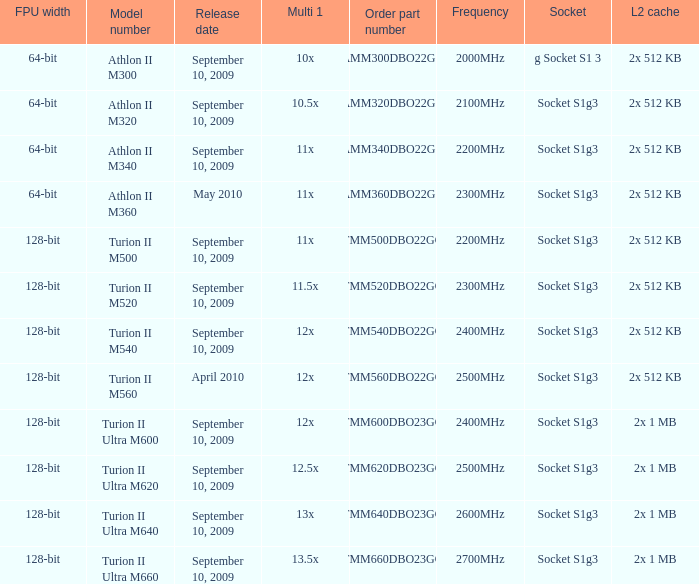Parse the full table. {'header': ['FPU width', 'Model number', 'Release date', 'Multi 1', 'Order part number', 'Frequency', 'Socket', 'L2 cache'], 'rows': [['64-bit', 'Athlon II M300', 'September 10, 2009', '10x', 'AMM300DBO22GQ', '2000MHz', 'g Socket S1 3', '2x 512 KB'], ['64-bit', 'Athlon II M320', 'September 10, 2009', '10.5x', 'AMM320DBO22GQ', '2100MHz', 'Socket S1g3', '2x 512 KB'], ['64-bit', 'Athlon II M340', 'September 10, 2009', '11x', 'AMM340DBO22GQ', '2200MHz', 'Socket S1g3', '2x 512 KB'], ['64-bit', 'Athlon II M360', 'May 2010', '11x', 'AMM360DBO22GQ', '2300MHz', 'Socket S1g3', '2x 512 KB'], ['128-bit', 'Turion II M500', 'September 10, 2009', '11x', 'TMM500DBO22GQ', '2200MHz', 'Socket S1g3', '2x 512 KB'], ['128-bit', 'Turion II M520', 'September 10, 2009', '11.5x', 'TMM520DBO22GQ', '2300MHz', 'Socket S1g3', '2x 512 KB'], ['128-bit', 'Turion II M540', 'September 10, 2009', '12x', 'TMM540DBO22GQ', '2400MHz', 'Socket S1g3', '2x 512 KB'], ['128-bit', 'Turion II M560', 'April 2010', '12x', 'TMM560DBO22GQ', '2500MHz', 'Socket S1g3', '2x 512 KB'], ['128-bit', 'Turion II Ultra M600', 'September 10, 2009', '12x', 'TMM600DBO23GQ', '2400MHz', 'Socket S1g3', '2x 1 MB'], ['128-bit', 'Turion II Ultra M620', 'September 10, 2009', '12.5x', 'TMM620DBO23GQ', '2500MHz', 'Socket S1g3', '2x 1 MB'], ['128-bit', 'Turion II Ultra M640', 'September 10, 2009', '13x', 'TMM640DBO23GQ', '2600MHz', 'Socket S1g3', '2x 1 MB'], ['128-bit', 'Turion II Ultra M660', 'September 10, 2009', '13.5x', 'TMM660DBO23GQ', '2700MHz', 'Socket S1g3', '2x 1 MB']]} What is the release date of the 2x 512 kb L2 cache with a 11x multi 1, and a FPU width of 128-bit? September 10, 2009. 